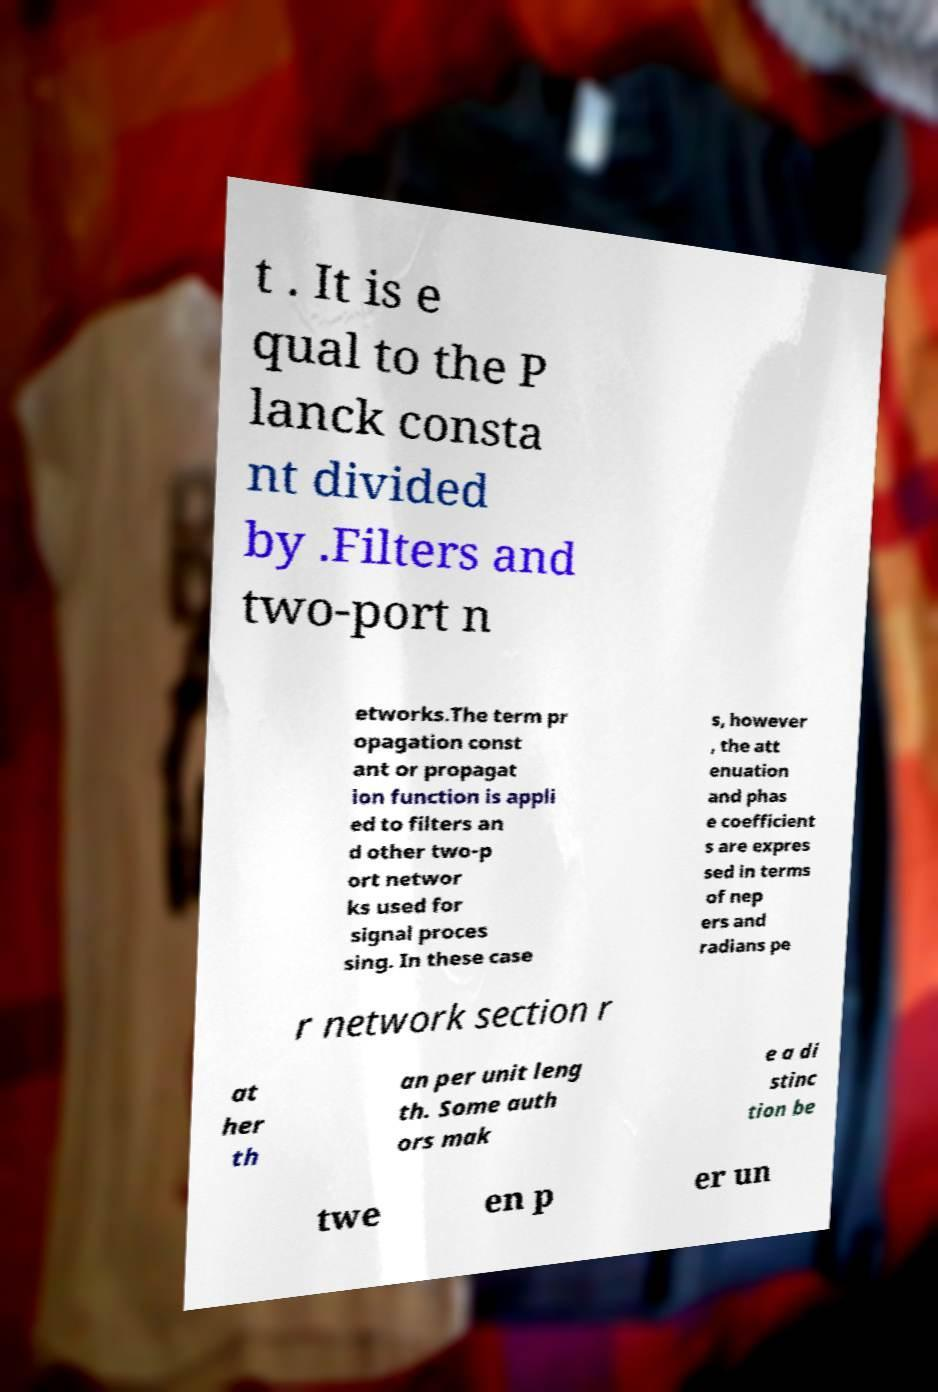Please read and relay the text visible in this image. What does it say? t . It is e qual to the P lanck consta nt divided by .Filters and two-port n etworks.The term pr opagation const ant or propagat ion function is appli ed to filters an d other two-p ort networ ks used for signal proces sing. In these case s, however , the att enuation and phas e coefficient s are expres sed in terms of nep ers and radians pe r network section r at her th an per unit leng th. Some auth ors mak e a di stinc tion be twe en p er un 